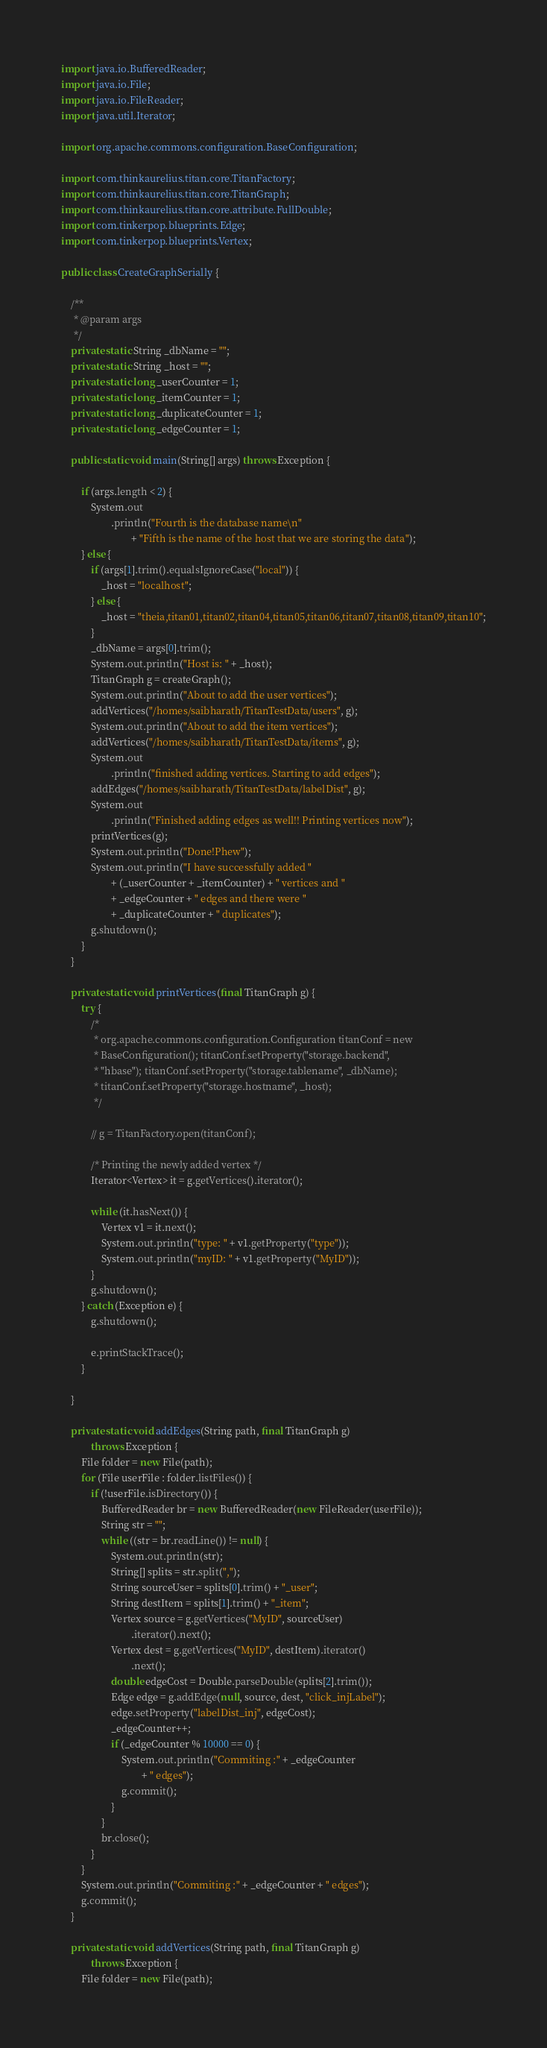<code> <loc_0><loc_0><loc_500><loc_500><_Java_>import java.io.BufferedReader;
import java.io.File;
import java.io.FileReader;
import java.util.Iterator;

import org.apache.commons.configuration.BaseConfiguration;

import com.thinkaurelius.titan.core.TitanFactory;
import com.thinkaurelius.titan.core.TitanGraph;
import com.thinkaurelius.titan.core.attribute.FullDouble;
import com.tinkerpop.blueprints.Edge;
import com.tinkerpop.blueprints.Vertex;

public class CreateGraphSerially {

	/**
	 * @param args
	 */
	private static String _dbName = "";
	private static String _host = "";
	private static long _userCounter = 1;
	private static long _itemCounter = 1;
	private static long _duplicateCounter = 1;
	private static long _edgeCounter = 1;

	public static void main(String[] args) throws Exception {

		if (args.length < 2) {
			System.out
					.println("Fourth is the database name\n"
							+ "Fifth is the name of the host that we are storing the data");
		} else {
			if (args[1].trim().equalsIgnoreCase("local")) {
				_host = "localhost";
			} else {
				_host = "theia,titan01,titan02,titan04,titan05,titan06,titan07,titan08,titan09,titan10";
			}
			_dbName = args[0].trim();
			System.out.println("Host is: " + _host);
			TitanGraph g = createGraph();
			System.out.println("About to add the user vertices");
			addVertices("/homes/saibharath/TitanTestData/users", g);
			System.out.println("About to add the item vertices");
			addVertices("/homes/saibharath/TitanTestData/items", g);
			System.out
					.println("finished adding vertices. Starting to add edges");
			addEdges("/homes/saibharath/TitanTestData/labelDist", g);
			System.out
					.println("Finished adding edges as well!! Printing vertices now");
			printVertices(g);
			System.out.println("Done!Phew");
			System.out.println("I have successfully added "
					+ (_userCounter + _itemCounter) + " vertices and "
					+ _edgeCounter + " edges and there were "
					+ _duplicateCounter + " duplicates");
			g.shutdown();
		}
	}

	private static void printVertices(final TitanGraph g) {
		try {
			/*
			 * org.apache.commons.configuration.Configuration titanConf = new
			 * BaseConfiguration(); titanConf.setProperty("storage.backend",
			 * "hbase"); titanConf.setProperty("storage.tablename", _dbName);
			 * titanConf.setProperty("storage.hostname", _host);
			 */

			// g = TitanFactory.open(titanConf);

			/* Printing the newly added vertex */
			Iterator<Vertex> it = g.getVertices().iterator();

			while (it.hasNext()) {
				Vertex v1 = it.next();
				System.out.println("type: " + v1.getProperty("type"));
				System.out.println("myID: " + v1.getProperty("MyID"));
			}
			g.shutdown();
		} catch (Exception e) {
			g.shutdown();

			e.printStackTrace();
		}

	}

	private static void addEdges(String path, final TitanGraph g)
			throws Exception {
		File folder = new File(path);
		for (File userFile : folder.listFiles()) {
			if (!userFile.isDirectory()) {
				BufferedReader br = new BufferedReader(new FileReader(userFile));
				String str = "";
				while ((str = br.readLine()) != null) {
					System.out.println(str);
					String[] splits = str.split(",");
					String sourceUser = splits[0].trim() + "_user";
					String destItem = splits[1].trim() + "_item";
					Vertex source = g.getVertices("MyID", sourceUser)
							.iterator().next();
					Vertex dest = g.getVertices("MyID", destItem).iterator()
							.next();
					double edgeCost = Double.parseDouble(splits[2].trim());
					Edge edge = g.addEdge(null, source, dest, "click_injLabel");
					edge.setProperty("labelDist_inj", edgeCost);
					_edgeCounter++;
					if (_edgeCounter % 10000 == 0) {
						System.out.println("Commiting :" + _edgeCounter
								+ " edges");
						g.commit();
					}
				}
				br.close();
			}
		}
		System.out.println("Commiting :" + _edgeCounter + " edges");
		g.commit();
	}

	private static void addVertices(String path, final TitanGraph g)
			throws Exception {
		File folder = new File(path);</code> 